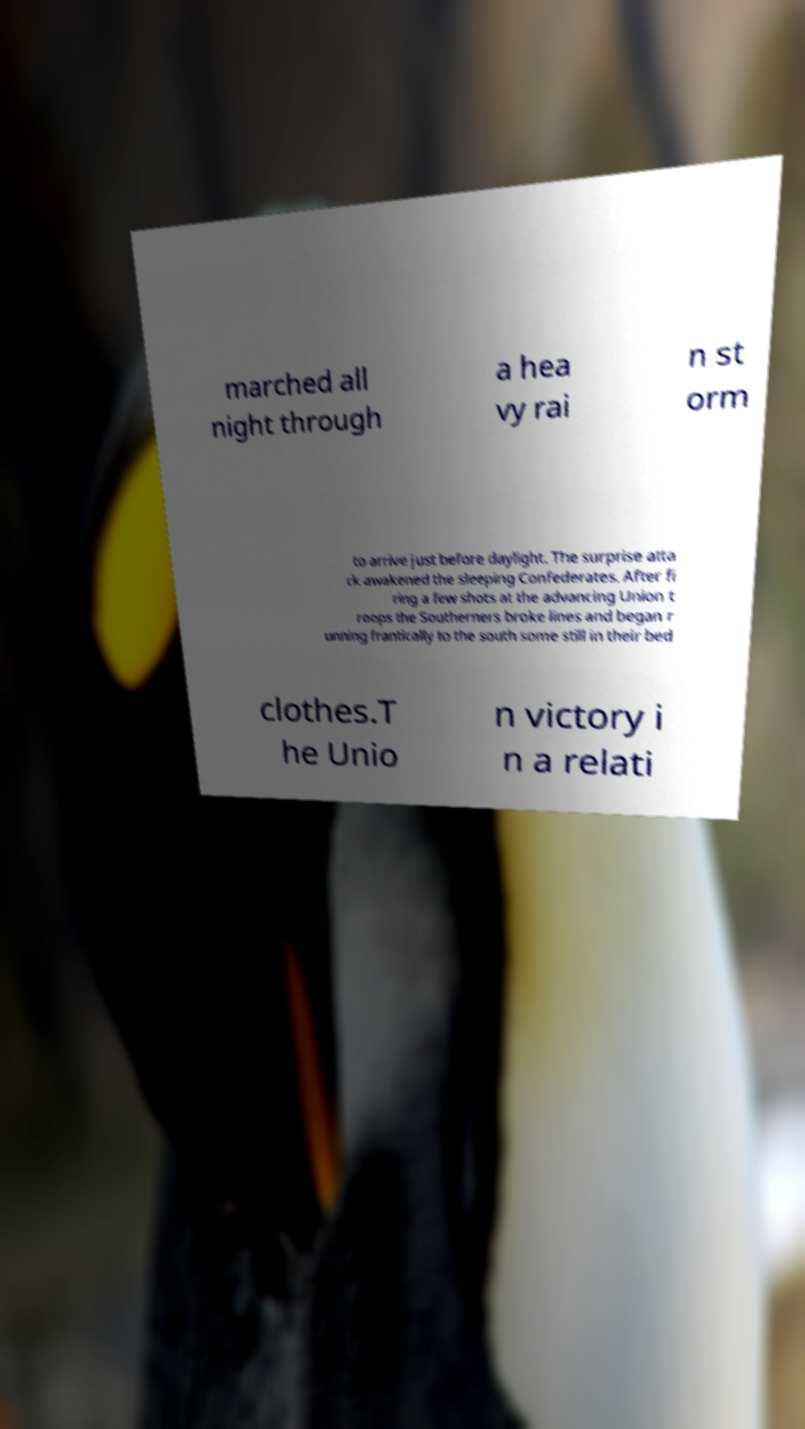Could you extract and type out the text from this image? marched all night through a hea vy rai n st orm to arrive just before daylight. The surprise atta ck awakened the sleeping Confederates. After fi ring a few shots at the advancing Union t roops the Southerners broke lines and began r unning frantically to the south some still in their bed clothes.T he Unio n victory i n a relati 